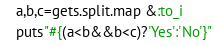Convert code to text. <code><loc_0><loc_0><loc_500><loc_500><_Ruby_>a,b,c=gets.split.map &:to_i
puts"#{(a<b&&b<c)?'Yes':'No'}"</code> 